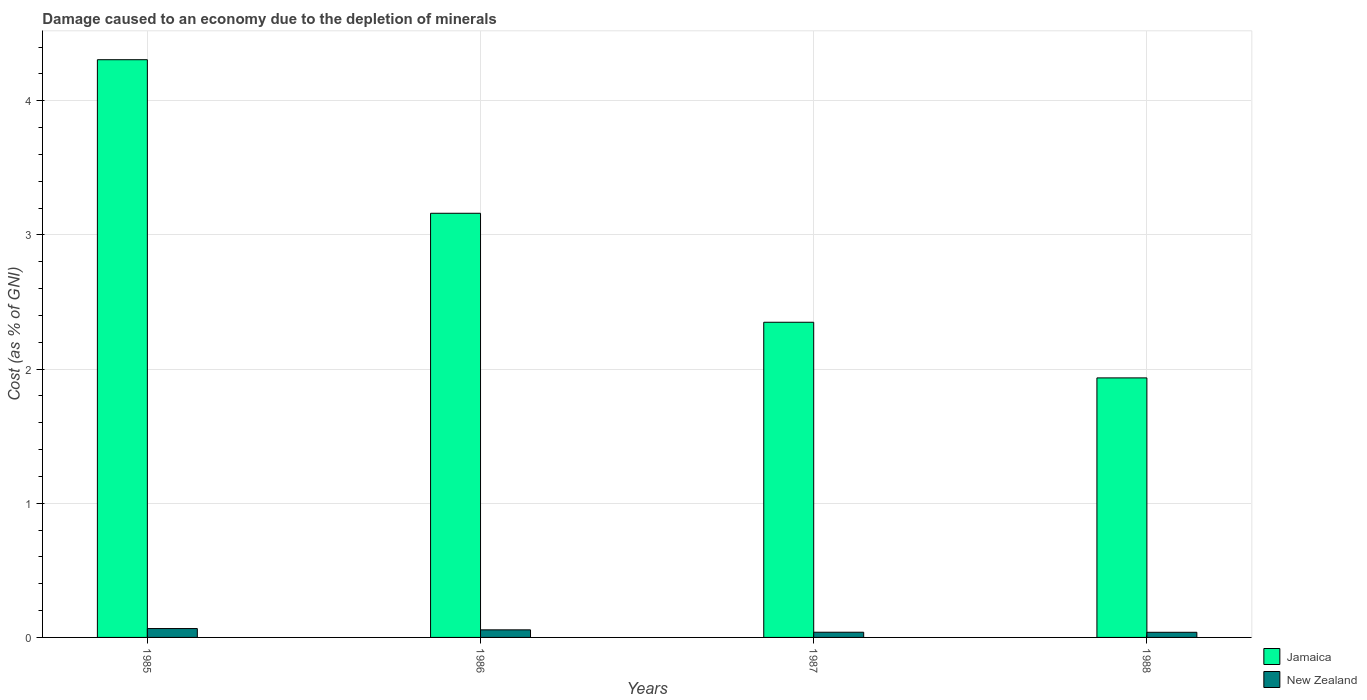How many groups of bars are there?
Keep it short and to the point. 4. Are the number of bars per tick equal to the number of legend labels?
Your answer should be very brief. Yes. Are the number of bars on each tick of the X-axis equal?
Give a very brief answer. Yes. How many bars are there on the 1st tick from the left?
Offer a terse response. 2. How many bars are there on the 1st tick from the right?
Make the answer very short. 2. What is the label of the 1st group of bars from the left?
Your answer should be very brief. 1985. What is the cost of damage caused due to the depletion of minerals in New Zealand in 1988?
Offer a very short reply. 0.04. Across all years, what is the maximum cost of damage caused due to the depletion of minerals in Jamaica?
Offer a terse response. 4.31. Across all years, what is the minimum cost of damage caused due to the depletion of minerals in Jamaica?
Provide a short and direct response. 1.93. In which year was the cost of damage caused due to the depletion of minerals in Jamaica minimum?
Make the answer very short. 1988. What is the total cost of damage caused due to the depletion of minerals in New Zealand in the graph?
Offer a terse response. 0.2. What is the difference between the cost of damage caused due to the depletion of minerals in New Zealand in 1985 and that in 1987?
Your answer should be compact. 0.03. What is the difference between the cost of damage caused due to the depletion of minerals in Jamaica in 1986 and the cost of damage caused due to the depletion of minerals in New Zealand in 1987?
Ensure brevity in your answer.  3.12. What is the average cost of damage caused due to the depletion of minerals in New Zealand per year?
Ensure brevity in your answer.  0.05. In the year 1988, what is the difference between the cost of damage caused due to the depletion of minerals in Jamaica and cost of damage caused due to the depletion of minerals in New Zealand?
Give a very brief answer. 1.9. In how many years, is the cost of damage caused due to the depletion of minerals in New Zealand greater than 3.2 %?
Make the answer very short. 0. What is the ratio of the cost of damage caused due to the depletion of minerals in New Zealand in 1985 to that in 1988?
Your answer should be compact. 1.73. Is the difference between the cost of damage caused due to the depletion of minerals in Jamaica in 1986 and 1987 greater than the difference between the cost of damage caused due to the depletion of minerals in New Zealand in 1986 and 1987?
Offer a terse response. Yes. What is the difference between the highest and the second highest cost of damage caused due to the depletion of minerals in New Zealand?
Keep it short and to the point. 0.01. What is the difference between the highest and the lowest cost of damage caused due to the depletion of minerals in New Zealand?
Offer a terse response. 0.03. In how many years, is the cost of damage caused due to the depletion of minerals in Jamaica greater than the average cost of damage caused due to the depletion of minerals in Jamaica taken over all years?
Ensure brevity in your answer.  2. What does the 1st bar from the left in 1985 represents?
Ensure brevity in your answer.  Jamaica. What does the 2nd bar from the right in 1986 represents?
Provide a succinct answer. Jamaica. How many bars are there?
Your answer should be very brief. 8. Are all the bars in the graph horizontal?
Offer a terse response. No. What is the difference between two consecutive major ticks on the Y-axis?
Provide a short and direct response. 1. Does the graph contain any zero values?
Ensure brevity in your answer.  No. Does the graph contain grids?
Make the answer very short. Yes. Where does the legend appear in the graph?
Offer a very short reply. Bottom right. What is the title of the graph?
Provide a succinct answer. Damage caused to an economy due to the depletion of minerals. Does "Sub-Saharan Africa (all income levels)" appear as one of the legend labels in the graph?
Make the answer very short. No. What is the label or title of the X-axis?
Your answer should be compact. Years. What is the label or title of the Y-axis?
Ensure brevity in your answer.  Cost (as % of GNI). What is the Cost (as % of GNI) of Jamaica in 1985?
Offer a terse response. 4.31. What is the Cost (as % of GNI) of New Zealand in 1985?
Ensure brevity in your answer.  0.07. What is the Cost (as % of GNI) of Jamaica in 1986?
Provide a succinct answer. 3.16. What is the Cost (as % of GNI) of New Zealand in 1986?
Make the answer very short. 0.06. What is the Cost (as % of GNI) of Jamaica in 1987?
Provide a short and direct response. 2.35. What is the Cost (as % of GNI) in New Zealand in 1987?
Give a very brief answer. 0.04. What is the Cost (as % of GNI) in Jamaica in 1988?
Make the answer very short. 1.93. What is the Cost (as % of GNI) in New Zealand in 1988?
Your answer should be compact. 0.04. Across all years, what is the maximum Cost (as % of GNI) in Jamaica?
Provide a short and direct response. 4.31. Across all years, what is the maximum Cost (as % of GNI) in New Zealand?
Provide a succinct answer. 0.07. Across all years, what is the minimum Cost (as % of GNI) in Jamaica?
Your answer should be compact. 1.93. Across all years, what is the minimum Cost (as % of GNI) in New Zealand?
Your answer should be compact. 0.04. What is the total Cost (as % of GNI) in Jamaica in the graph?
Provide a succinct answer. 11.75. What is the total Cost (as % of GNI) of New Zealand in the graph?
Ensure brevity in your answer.  0.2. What is the difference between the Cost (as % of GNI) in Jamaica in 1985 and that in 1986?
Offer a very short reply. 1.14. What is the difference between the Cost (as % of GNI) in New Zealand in 1985 and that in 1986?
Provide a short and direct response. 0.01. What is the difference between the Cost (as % of GNI) of Jamaica in 1985 and that in 1987?
Your answer should be compact. 1.96. What is the difference between the Cost (as % of GNI) in New Zealand in 1985 and that in 1987?
Provide a short and direct response. 0.03. What is the difference between the Cost (as % of GNI) in Jamaica in 1985 and that in 1988?
Your answer should be compact. 2.37. What is the difference between the Cost (as % of GNI) in New Zealand in 1985 and that in 1988?
Give a very brief answer. 0.03. What is the difference between the Cost (as % of GNI) of Jamaica in 1986 and that in 1987?
Ensure brevity in your answer.  0.81. What is the difference between the Cost (as % of GNI) in New Zealand in 1986 and that in 1987?
Keep it short and to the point. 0.02. What is the difference between the Cost (as % of GNI) of Jamaica in 1986 and that in 1988?
Make the answer very short. 1.23. What is the difference between the Cost (as % of GNI) of New Zealand in 1986 and that in 1988?
Make the answer very short. 0.02. What is the difference between the Cost (as % of GNI) in Jamaica in 1987 and that in 1988?
Keep it short and to the point. 0.41. What is the difference between the Cost (as % of GNI) in New Zealand in 1987 and that in 1988?
Ensure brevity in your answer.  0. What is the difference between the Cost (as % of GNI) of Jamaica in 1985 and the Cost (as % of GNI) of New Zealand in 1986?
Your answer should be compact. 4.25. What is the difference between the Cost (as % of GNI) in Jamaica in 1985 and the Cost (as % of GNI) in New Zealand in 1987?
Your answer should be very brief. 4.27. What is the difference between the Cost (as % of GNI) of Jamaica in 1985 and the Cost (as % of GNI) of New Zealand in 1988?
Provide a succinct answer. 4.27. What is the difference between the Cost (as % of GNI) of Jamaica in 1986 and the Cost (as % of GNI) of New Zealand in 1987?
Provide a short and direct response. 3.12. What is the difference between the Cost (as % of GNI) in Jamaica in 1986 and the Cost (as % of GNI) in New Zealand in 1988?
Your answer should be very brief. 3.12. What is the difference between the Cost (as % of GNI) in Jamaica in 1987 and the Cost (as % of GNI) in New Zealand in 1988?
Offer a very short reply. 2.31. What is the average Cost (as % of GNI) of Jamaica per year?
Provide a short and direct response. 2.94. What is the average Cost (as % of GNI) in New Zealand per year?
Give a very brief answer. 0.05. In the year 1985, what is the difference between the Cost (as % of GNI) in Jamaica and Cost (as % of GNI) in New Zealand?
Make the answer very short. 4.24. In the year 1986, what is the difference between the Cost (as % of GNI) in Jamaica and Cost (as % of GNI) in New Zealand?
Your response must be concise. 3.1. In the year 1987, what is the difference between the Cost (as % of GNI) of Jamaica and Cost (as % of GNI) of New Zealand?
Your answer should be very brief. 2.31. In the year 1988, what is the difference between the Cost (as % of GNI) in Jamaica and Cost (as % of GNI) in New Zealand?
Offer a very short reply. 1.9. What is the ratio of the Cost (as % of GNI) of Jamaica in 1985 to that in 1986?
Your answer should be very brief. 1.36. What is the ratio of the Cost (as % of GNI) of New Zealand in 1985 to that in 1986?
Offer a very short reply. 1.17. What is the ratio of the Cost (as % of GNI) of Jamaica in 1985 to that in 1987?
Provide a short and direct response. 1.83. What is the ratio of the Cost (as % of GNI) of New Zealand in 1985 to that in 1987?
Give a very brief answer. 1.71. What is the ratio of the Cost (as % of GNI) of Jamaica in 1985 to that in 1988?
Provide a succinct answer. 2.23. What is the ratio of the Cost (as % of GNI) of New Zealand in 1985 to that in 1988?
Your answer should be very brief. 1.73. What is the ratio of the Cost (as % of GNI) of Jamaica in 1986 to that in 1987?
Your answer should be compact. 1.35. What is the ratio of the Cost (as % of GNI) in New Zealand in 1986 to that in 1987?
Your answer should be very brief. 1.46. What is the ratio of the Cost (as % of GNI) of Jamaica in 1986 to that in 1988?
Provide a short and direct response. 1.63. What is the ratio of the Cost (as % of GNI) in New Zealand in 1986 to that in 1988?
Provide a short and direct response. 1.48. What is the ratio of the Cost (as % of GNI) in Jamaica in 1987 to that in 1988?
Keep it short and to the point. 1.21. What is the ratio of the Cost (as % of GNI) in New Zealand in 1987 to that in 1988?
Your response must be concise. 1.01. What is the difference between the highest and the second highest Cost (as % of GNI) of Jamaica?
Make the answer very short. 1.14. What is the difference between the highest and the second highest Cost (as % of GNI) of New Zealand?
Your answer should be very brief. 0.01. What is the difference between the highest and the lowest Cost (as % of GNI) of Jamaica?
Provide a short and direct response. 2.37. What is the difference between the highest and the lowest Cost (as % of GNI) of New Zealand?
Provide a short and direct response. 0.03. 